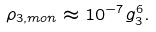<formula> <loc_0><loc_0><loc_500><loc_500>\rho _ { 3 , { m o n } } \approx 1 0 ^ { - 7 } g _ { 3 } ^ { 6 } .</formula> 